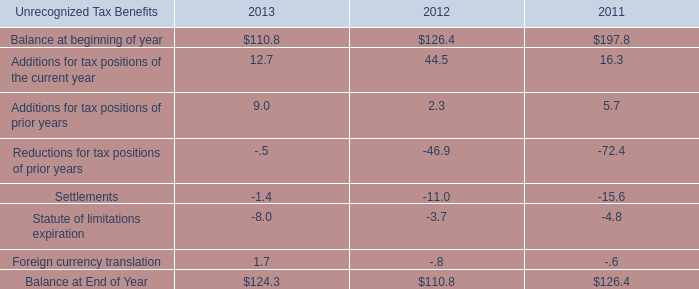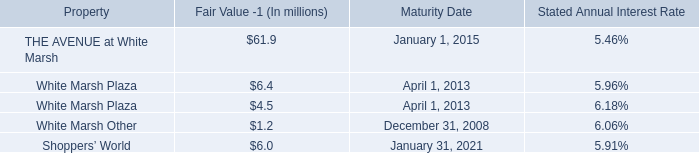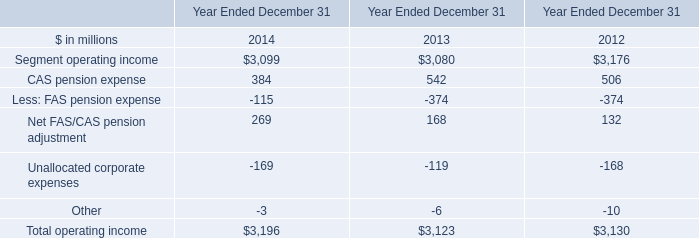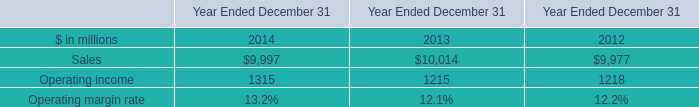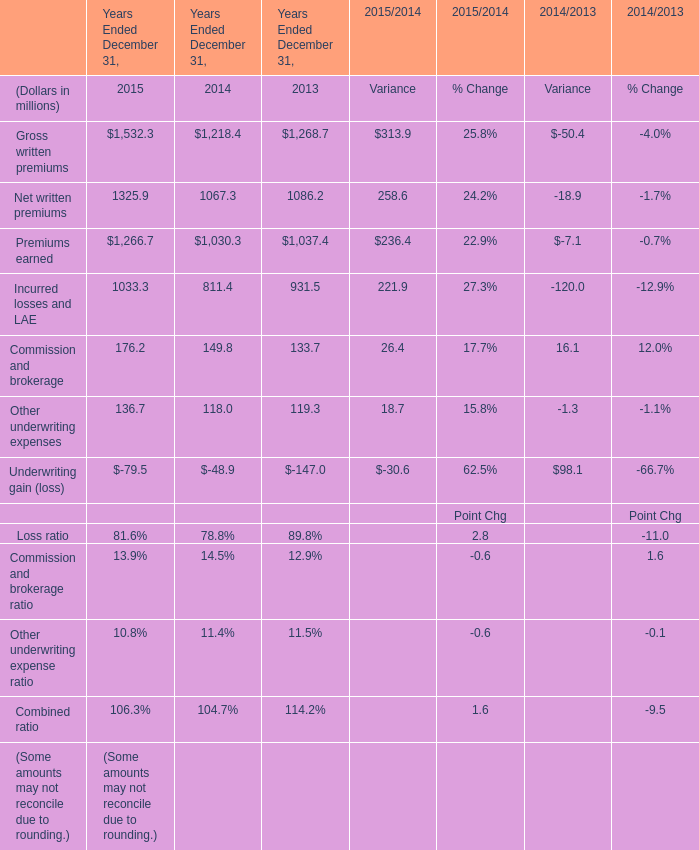what's the total amount of Segment operating income of Year Ended December 31 2012, and Gross written premiums of Years Ended December 31, 2013 ? 
Computations: (3176.0 + 1268.7)
Answer: 4444.7. 